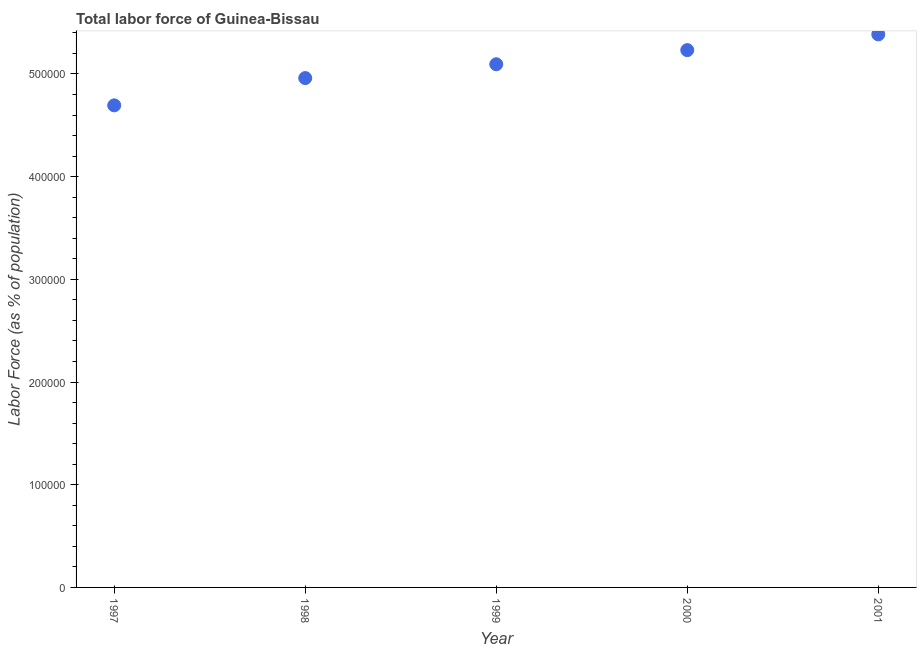What is the total labor force in 1999?
Your answer should be very brief. 5.09e+05. Across all years, what is the maximum total labor force?
Give a very brief answer. 5.39e+05. Across all years, what is the minimum total labor force?
Your response must be concise. 4.69e+05. What is the sum of the total labor force?
Your response must be concise. 2.54e+06. What is the difference between the total labor force in 2000 and 2001?
Your answer should be compact. -1.53e+04. What is the average total labor force per year?
Provide a succinct answer. 5.07e+05. What is the median total labor force?
Give a very brief answer. 5.09e+05. Do a majority of the years between 1997 and 1998 (inclusive) have total labor force greater than 520000 %?
Offer a terse response. No. What is the ratio of the total labor force in 1997 to that in 2001?
Make the answer very short. 0.87. What is the difference between the highest and the second highest total labor force?
Make the answer very short. 1.53e+04. What is the difference between the highest and the lowest total labor force?
Make the answer very short. 6.91e+04. Does the total labor force monotonically increase over the years?
Provide a succinct answer. Yes. How many dotlines are there?
Keep it short and to the point. 1. What is the difference between two consecutive major ticks on the Y-axis?
Provide a short and direct response. 1.00e+05. Does the graph contain any zero values?
Provide a succinct answer. No. What is the title of the graph?
Ensure brevity in your answer.  Total labor force of Guinea-Bissau. What is the label or title of the X-axis?
Offer a very short reply. Year. What is the label or title of the Y-axis?
Offer a terse response. Labor Force (as % of population). What is the Labor Force (as % of population) in 1997?
Give a very brief answer. 4.69e+05. What is the Labor Force (as % of population) in 1998?
Ensure brevity in your answer.  4.96e+05. What is the Labor Force (as % of population) in 1999?
Ensure brevity in your answer.  5.09e+05. What is the Labor Force (as % of population) in 2000?
Keep it short and to the point. 5.23e+05. What is the Labor Force (as % of population) in 2001?
Provide a succinct answer. 5.39e+05. What is the difference between the Labor Force (as % of population) in 1997 and 1998?
Offer a terse response. -2.66e+04. What is the difference between the Labor Force (as % of population) in 1997 and 1999?
Your answer should be compact. -4.00e+04. What is the difference between the Labor Force (as % of population) in 1997 and 2000?
Your response must be concise. -5.38e+04. What is the difference between the Labor Force (as % of population) in 1997 and 2001?
Ensure brevity in your answer.  -6.91e+04. What is the difference between the Labor Force (as % of population) in 1998 and 1999?
Your response must be concise. -1.35e+04. What is the difference between the Labor Force (as % of population) in 1998 and 2000?
Make the answer very short. -2.72e+04. What is the difference between the Labor Force (as % of population) in 1998 and 2001?
Offer a terse response. -4.26e+04. What is the difference between the Labor Force (as % of population) in 1999 and 2000?
Your answer should be very brief. -1.38e+04. What is the difference between the Labor Force (as % of population) in 1999 and 2001?
Provide a succinct answer. -2.91e+04. What is the difference between the Labor Force (as % of population) in 2000 and 2001?
Your answer should be very brief. -1.53e+04. What is the ratio of the Labor Force (as % of population) in 1997 to that in 1998?
Give a very brief answer. 0.95. What is the ratio of the Labor Force (as % of population) in 1997 to that in 1999?
Offer a very short reply. 0.92. What is the ratio of the Labor Force (as % of population) in 1997 to that in 2000?
Give a very brief answer. 0.9. What is the ratio of the Labor Force (as % of population) in 1997 to that in 2001?
Make the answer very short. 0.87. What is the ratio of the Labor Force (as % of population) in 1998 to that in 1999?
Make the answer very short. 0.97. What is the ratio of the Labor Force (as % of population) in 1998 to that in 2000?
Give a very brief answer. 0.95. What is the ratio of the Labor Force (as % of population) in 1998 to that in 2001?
Your answer should be very brief. 0.92. What is the ratio of the Labor Force (as % of population) in 1999 to that in 2000?
Keep it short and to the point. 0.97. What is the ratio of the Labor Force (as % of population) in 1999 to that in 2001?
Provide a short and direct response. 0.95. What is the ratio of the Labor Force (as % of population) in 2000 to that in 2001?
Your answer should be compact. 0.97. 